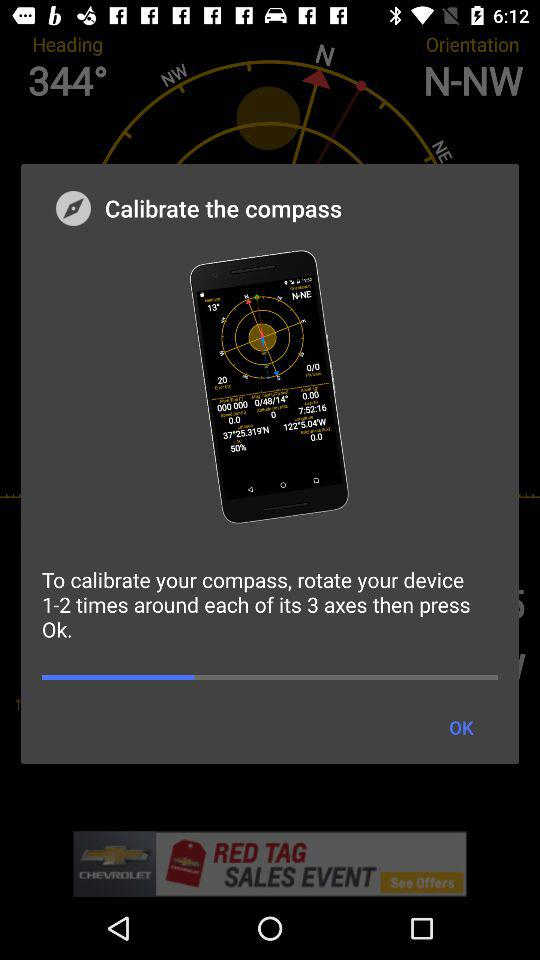How many axes does my device have?
Answer the question using a single word or phrase. 3 